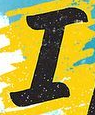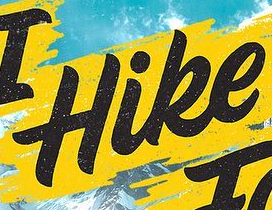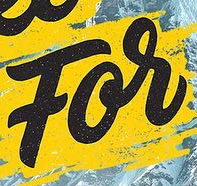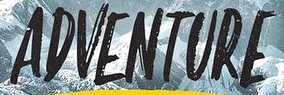Transcribe the words shown in these images in order, separated by a semicolon. I; Hike; For; ADVENTURE 